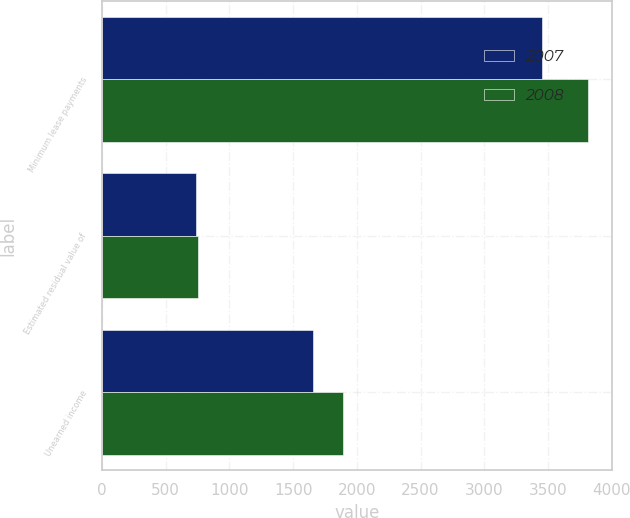Convert chart. <chart><loc_0><loc_0><loc_500><loc_500><stacked_bar_chart><ecel><fcel>Minimum lease payments<fcel>Estimated residual value of<fcel>Unearned income<nl><fcel>2007<fcel>3451<fcel>735<fcel>1658<nl><fcel>2008<fcel>3814<fcel>751<fcel>1889<nl></chart> 